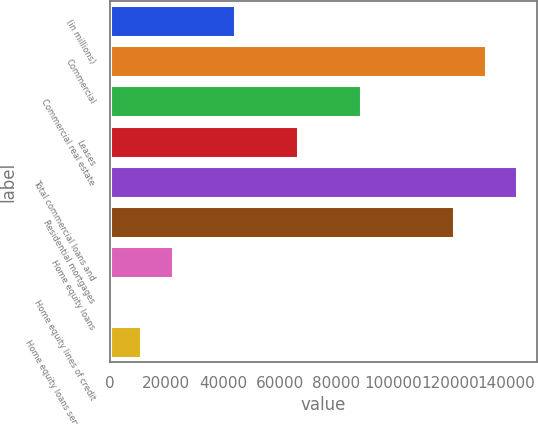Convert chart to OTSL. <chart><loc_0><loc_0><loc_500><loc_500><bar_chart><fcel>(in millions)<fcel>Commercial<fcel>Commercial real estate<fcel>Leases<fcel>Total commercial loans and<fcel>Residential mortgages<fcel>Home equity loans<fcel>Home equity lines of credit<fcel>Home equity loans serviced by<nl><fcel>44336.2<fcel>132711<fcel>88523.4<fcel>66429.8<fcel>143757<fcel>121664<fcel>22242.6<fcel>149<fcel>11195.8<nl></chart> 